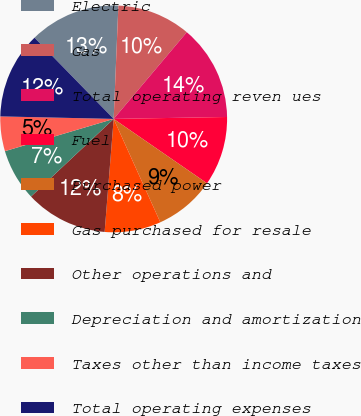Convert chart. <chart><loc_0><loc_0><loc_500><loc_500><pie_chart><fcel>Electric<fcel>Gas<fcel>Total operating reven ues<fcel>Fuel<fcel>Purchased power<fcel>Gas purchased for resale<fcel>Other operations and<fcel>Depreciation and amortization<fcel>Taxes other than income taxes<fcel>Total operating expenses<nl><fcel>12.96%<fcel>10.49%<fcel>13.58%<fcel>9.88%<fcel>8.64%<fcel>8.02%<fcel>11.73%<fcel>7.41%<fcel>4.94%<fcel>12.35%<nl></chart> 